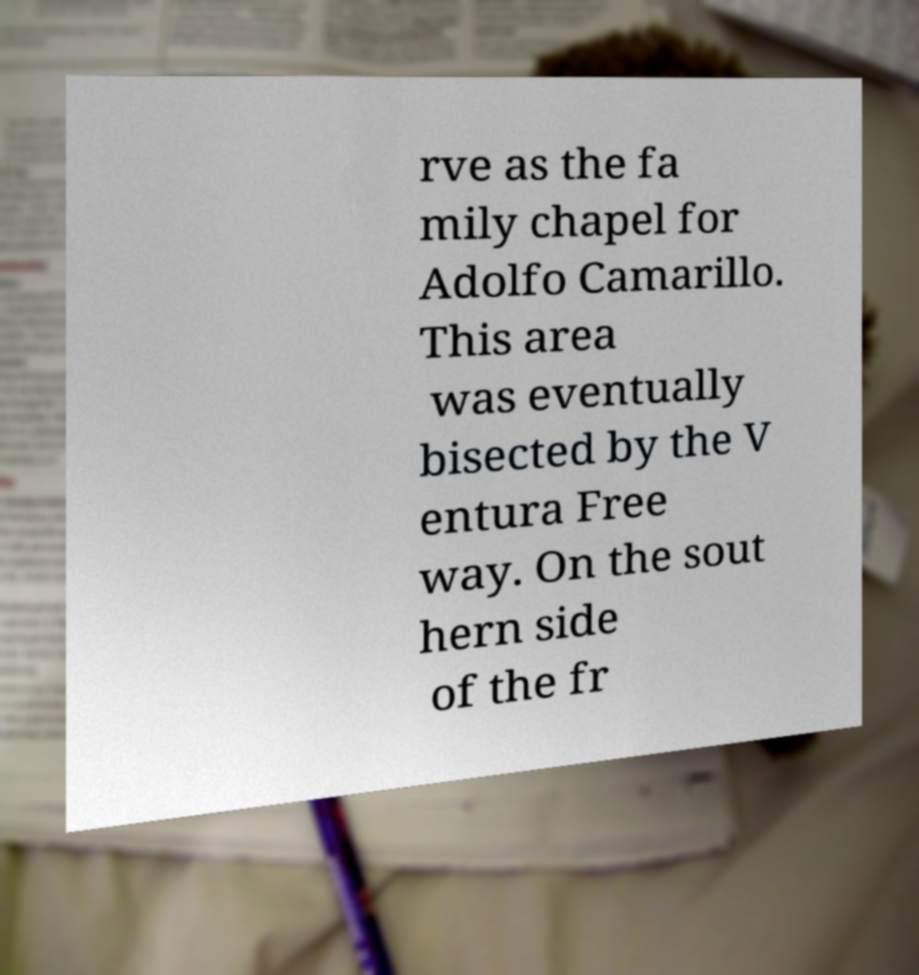For documentation purposes, I need the text within this image transcribed. Could you provide that? rve as the fa mily chapel for Adolfo Camarillo. This area was eventually bisected by the V entura Free way. On the sout hern side of the fr 